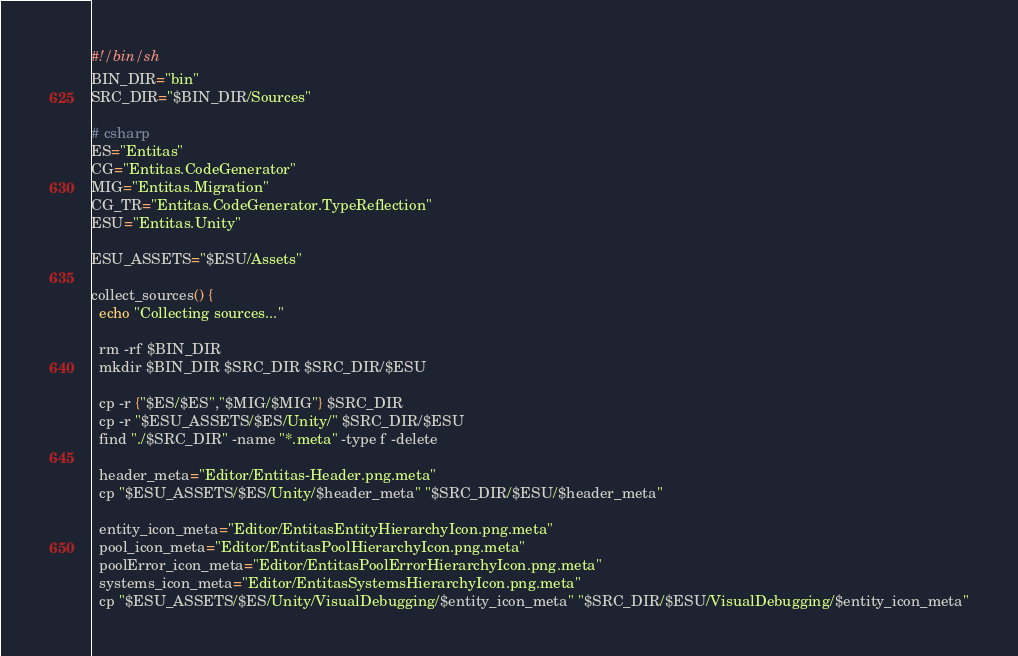<code> <loc_0><loc_0><loc_500><loc_500><_Bash_>#!/bin/sh
BIN_DIR="bin"
SRC_DIR="$BIN_DIR/Sources"

# csharp
ES="Entitas"
CG="Entitas.CodeGenerator"
MIG="Entitas.Migration"
CG_TR="Entitas.CodeGenerator.TypeReflection"
ESU="Entitas.Unity"

ESU_ASSETS="$ESU/Assets"

collect_sources() {
  echo "Collecting sources..."

  rm -rf $BIN_DIR
  mkdir $BIN_DIR $SRC_DIR $SRC_DIR/$ESU

  cp -r {"$ES/$ES","$MIG/$MIG"} $SRC_DIR
  cp -r "$ESU_ASSETS/$ES/Unity/" $SRC_DIR/$ESU
  find "./$SRC_DIR" -name "*.meta" -type f -delete

  header_meta="Editor/Entitas-Header.png.meta"
  cp "$ESU_ASSETS/$ES/Unity/$header_meta" "$SRC_DIR/$ESU/$header_meta"

  entity_icon_meta="Editor/EntitasEntityHierarchyIcon.png.meta"
  pool_icon_meta="Editor/EntitasPoolHierarchyIcon.png.meta"
  poolError_icon_meta="Editor/EntitasPoolErrorHierarchyIcon.png.meta"
  systems_icon_meta="Editor/EntitasSystemsHierarchyIcon.png.meta"
  cp "$ESU_ASSETS/$ES/Unity/VisualDebugging/$entity_icon_meta" "$SRC_DIR/$ESU/VisualDebugging/$entity_icon_meta"</code> 